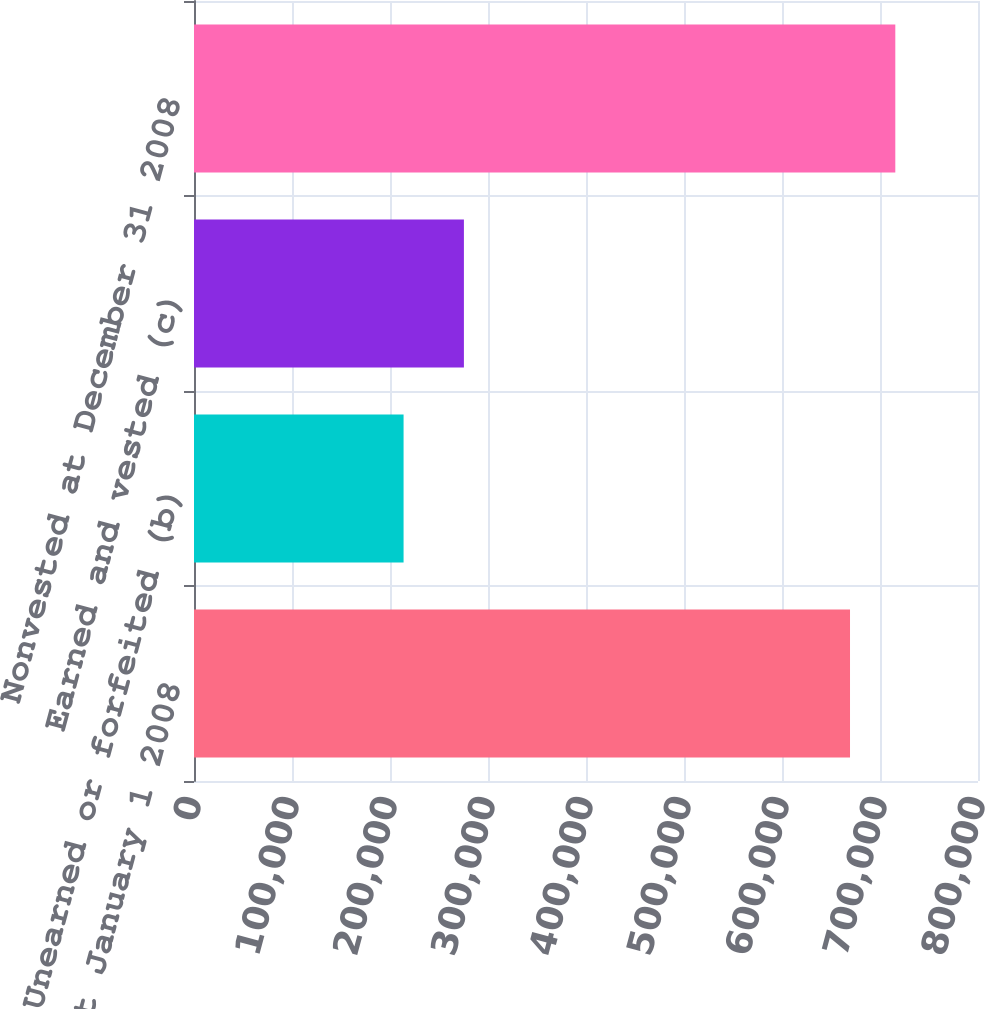Convert chart. <chart><loc_0><loc_0><loc_500><loc_500><bar_chart><fcel>Nonvested at January 1 2008<fcel>Unearned or forfeited (b)<fcel>Earned and vested (c)<fcel>Nonvested at December 31 2008<nl><fcel>669403<fcel>213854<fcel>275419<fcel>715615<nl></chart> 